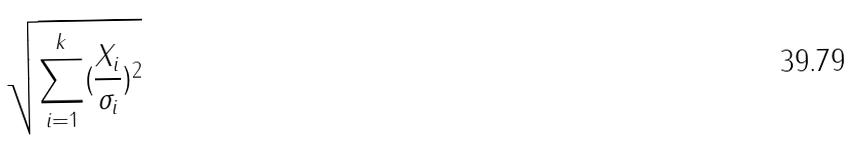Convert formula to latex. <formula><loc_0><loc_0><loc_500><loc_500>\sqrt { \sum _ { i = 1 } ^ { k } ( \frac { X _ { i } } { \sigma _ { i } } ) ^ { 2 } }</formula> 